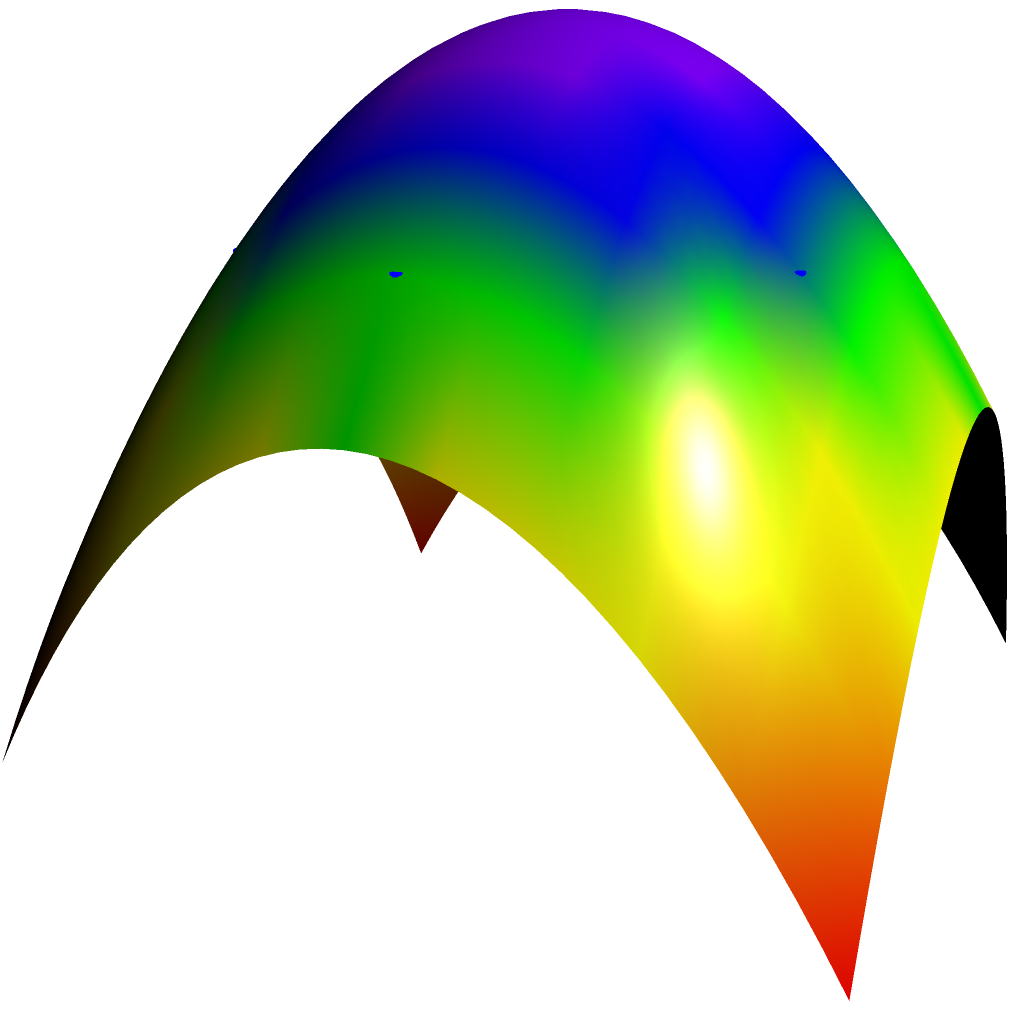Consider the polyhedral approximation of a curved surface in quantum error mitigation techniques. The figure shows a paraboloid surface $z = 1 - x^2 - y^2$ and its approximation using a regular hexagonal prism. If the radius of the inscribed circle of the hexagon is 0.8, calculate the maximum vertical error between the approximation and the actual surface. How might this error impact quantum error correction protocols? To solve this problem, we'll follow these steps:

1) The equation of the paraboloid is $z = 1 - x^2 - y^2$.

2) The hexagonal approximation has a radius of 0.8, so the maximum error will occur at the vertices of the hexagon.

3) At a vertex of the hexagon, $(x,y) = (0.8\cos(\theta), 0.8\sin(\theta))$ for some angle $\theta$.

4) The z-coordinate of a vertex on the hexagonal approximation is:
   $$z_{approx} = 1 - (0.8)^2 = 0.36$$

5) The actual z-coordinate on the paraboloid at a vertex point is:
   $$z_{actual} = 1 - (0.8\cos(\theta))^2 - (0.8\sin(\theta))^2 = 1 - 0.64(\cos^2(\theta) + \sin^2(\theta)) = 1 - 0.64 = 0.36$$

6) The vertical error is the difference between these:
   $$\text{Error} = |z_{approx} - z_{actual}| = |0.36 - 0.36| = 0$$

7) In this case, the maximum vertical error is 0, which is an ideal scenario.

Impact on quantum error correction protocols:
In practical applications, there would typically be some non-zero error. Even small errors in surface approximations can accumulate and affect the accuracy of quantum operations. In quantum error correction, the fidelity of operations is crucial. Errors in geometric representations could lead to imperfect gate operations, potentially introducing additional noise into the quantum system. This could increase the overall error rate, making it more challenging to achieve fault-tolerant quantum computation. However, in this idealized case with zero error, the impact on quantum error correction protocols would be minimal, allowing for more reliable quantum operations.
Answer: Maximum vertical error: 0. Impact: Minimal effect on quantum error correction protocols due to perfect approximation in this idealized case. 